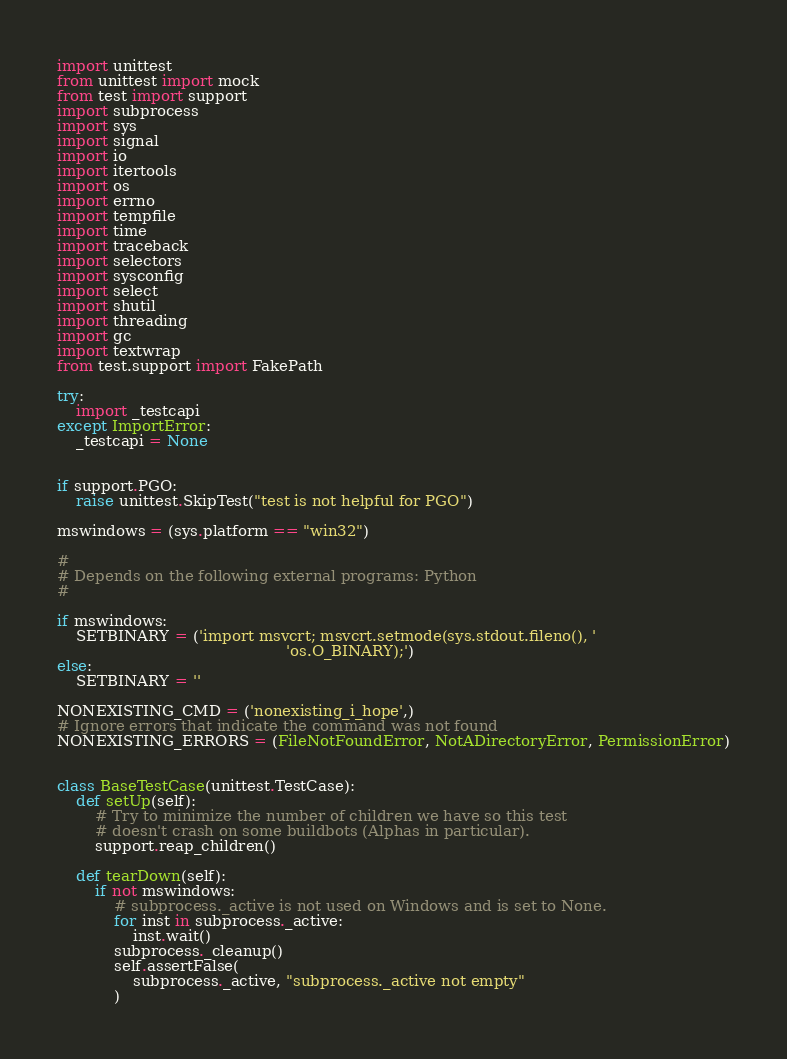Convert code to text. <code><loc_0><loc_0><loc_500><loc_500><_Python_>import unittest
from unittest import mock
from test import support
import subprocess
import sys
import signal
import io
import itertools
import os
import errno
import tempfile
import time
import traceback
import selectors
import sysconfig
import select
import shutil
import threading
import gc
import textwrap
from test.support import FakePath

try:
    import _testcapi
except ImportError:
    _testcapi = None


if support.PGO:
    raise unittest.SkipTest("test is not helpful for PGO")

mswindows = (sys.platform == "win32")

#
# Depends on the following external programs: Python
#

if mswindows:
    SETBINARY = ('import msvcrt; msvcrt.setmode(sys.stdout.fileno(), '
                                                'os.O_BINARY);')
else:
    SETBINARY = ''

NONEXISTING_CMD = ('nonexisting_i_hope',)
# Ignore errors that indicate the command was not found
NONEXISTING_ERRORS = (FileNotFoundError, NotADirectoryError, PermissionError)


class BaseTestCase(unittest.TestCase):
    def setUp(self):
        # Try to minimize the number of children we have so this test
        # doesn't crash on some buildbots (Alphas in particular).
        support.reap_children()

    def tearDown(self):
        if not mswindows:
            # subprocess._active is not used on Windows and is set to None.
            for inst in subprocess._active:
                inst.wait()
            subprocess._cleanup()
            self.assertFalse(
                subprocess._active, "subprocess._active not empty"
            )</code> 